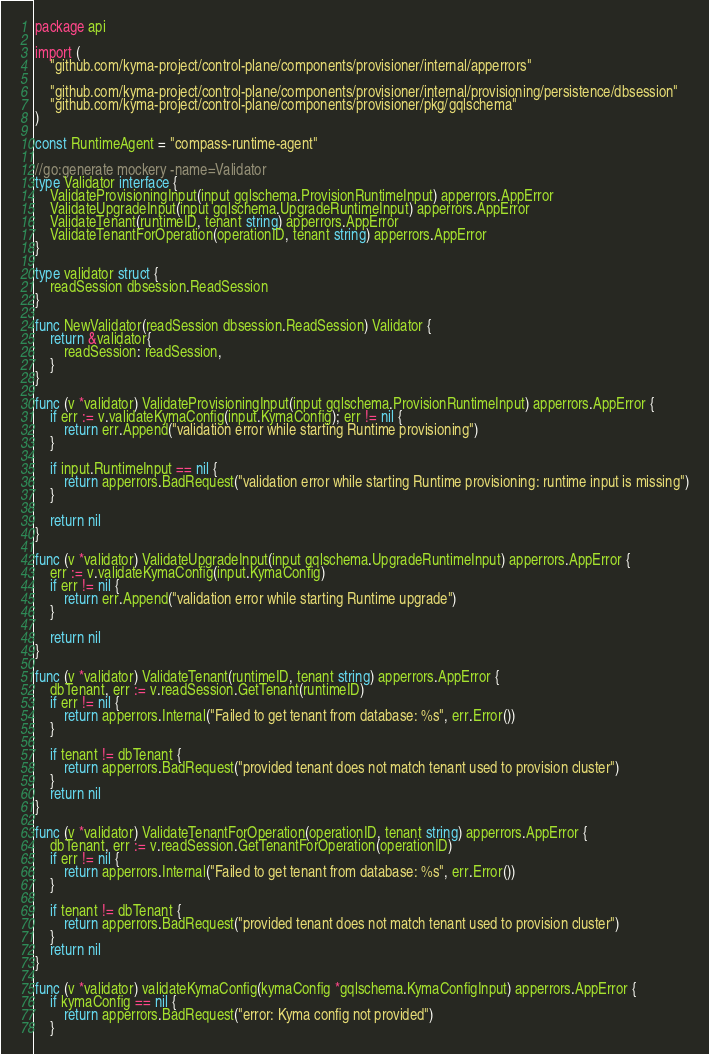Convert code to text. <code><loc_0><loc_0><loc_500><loc_500><_Go_>package api

import (
	"github.com/kyma-project/control-plane/components/provisioner/internal/apperrors"

	"github.com/kyma-project/control-plane/components/provisioner/internal/provisioning/persistence/dbsession"
	"github.com/kyma-project/control-plane/components/provisioner/pkg/gqlschema"
)

const RuntimeAgent = "compass-runtime-agent"

//go:generate mockery -name=Validator
type Validator interface {
	ValidateProvisioningInput(input gqlschema.ProvisionRuntimeInput) apperrors.AppError
	ValidateUpgradeInput(input gqlschema.UpgradeRuntimeInput) apperrors.AppError
	ValidateTenant(runtimeID, tenant string) apperrors.AppError
	ValidateTenantForOperation(operationID, tenant string) apperrors.AppError
}

type validator struct {
	readSession dbsession.ReadSession
}

func NewValidator(readSession dbsession.ReadSession) Validator {
	return &validator{
		readSession: readSession,
	}
}

func (v *validator) ValidateProvisioningInput(input gqlschema.ProvisionRuntimeInput) apperrors.AppError {
	if err := v.validateKymaConfig(input.KymaConfig); err != nil {
		return err.Append("validation error while starting Runtime provisioning")
	}

	if input.RuntimeInput == nil {
		return apperrors.BadRequest("validation error while starting Runtime provisioning: runtime input is missing")
	}

	return nil
}

func (v *validator) ValidateUpgradeInput(input gqlschema.UpgradeRuntimeInput) apperrors.AppError {
	err := v.validateKymaConfig(input.KymaConfig)
	if err != nil {
		return err.Append("validation error while starting Runtime upgrade")
	}

	return nil
}

func (v *validator) ValidateTenant(runtimeID, tenant string) apperrors.AppError {
	dbTenant, err := v.readSession.GetTenant(runtimeID)
	if err != nil {
		return apperrors.Internal("Failed to get tenant from database: %s", err.Error())
	}

	if tenant != dbTenant {
		return apperrors.BadRequest("provided tenant does not match tenant used to provision cluster")
	}
	return nil
}

func (v *validator) ValidateTenantForOperation(operationID, tenant string) apperrors.AppError {
	dbTenant, err := v.readSession.GetTenantForOperation(operationID)
	if err != nil {
		return apperrors.Internal("Failed to get tenant from database: %s", err.Error())
	}

	if tenant != dbTenant {
		return apperrors.BadRequest("provided tenant does not match tenant used to provision cluster")
	}
	return nil
}

func (v *validator) validateKymaConfig(kymaConfig *gqlschema.KymaConfigInput) apperrors.AppError {
	if kymaConfig == nil {
		return apperrors.BadRequest("error: Kyma config not provided")
	}
</code> 